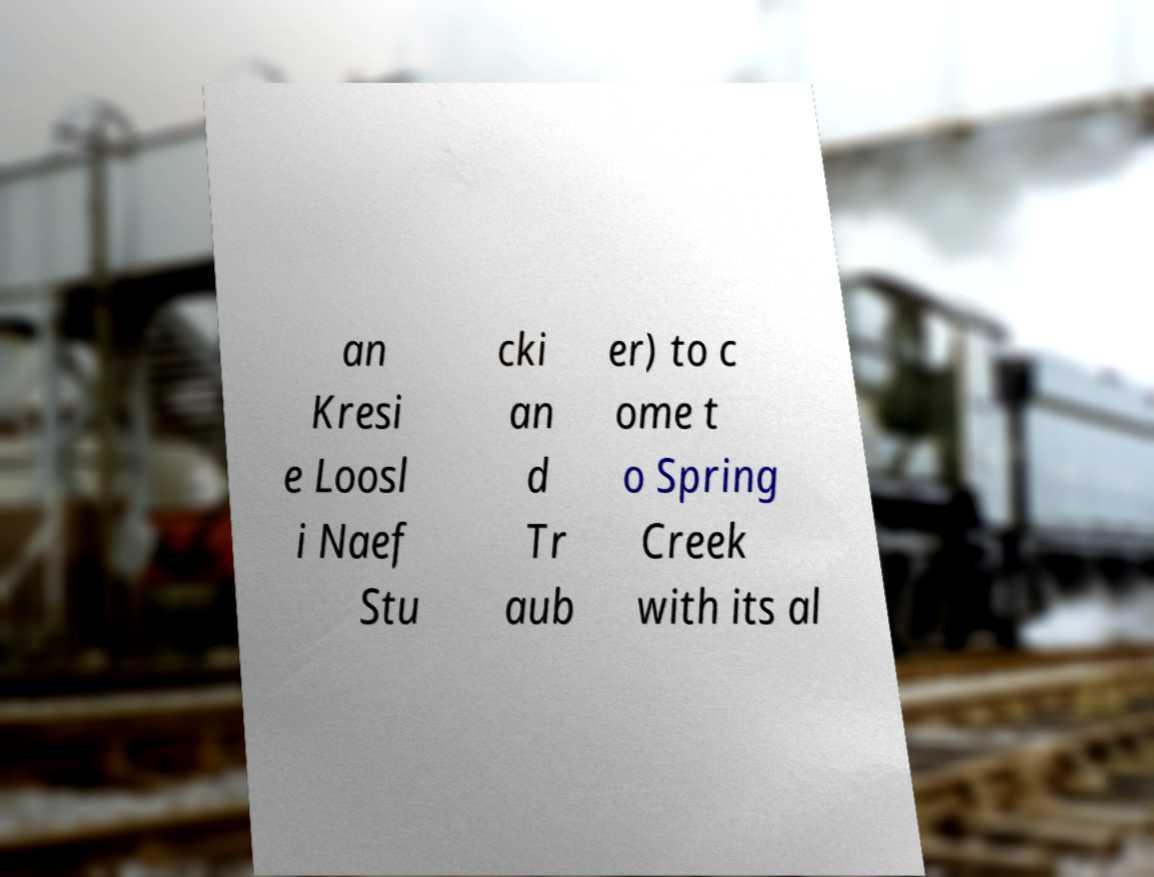I need the written content from this picture converted into text. Can you do that? an Kresi e Loosl i Naef Stu cki an d Tr aub er) to c ome t o Spring Creek with its al 